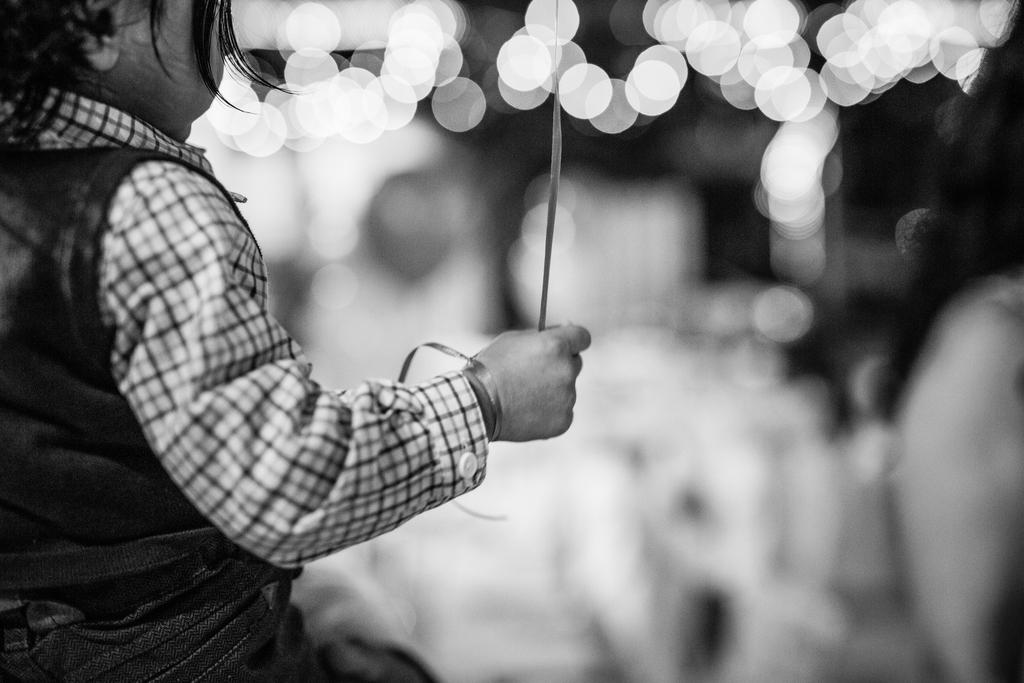What is the color scheme of the image? The image is black and white. What is the main subject of the image? There is a kid in the image. What is the kid holding in the image? The kid is holding an item. Can you describe the background of the image? The background behind the kid is blurred. What type of drug can be seen in the kid's hand in the image? There is no drug present in the image; the kid is holding an item, but it is not specified as a drug. 